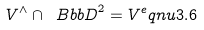Convert formula to latex. <formula><loc_0><loc_0><loc_500><loc_500>V ^ { \wedge } \cap { \ B b b D } ^ { 2 } = V ^ { e } q n u { 3 . 6 }</formula> 